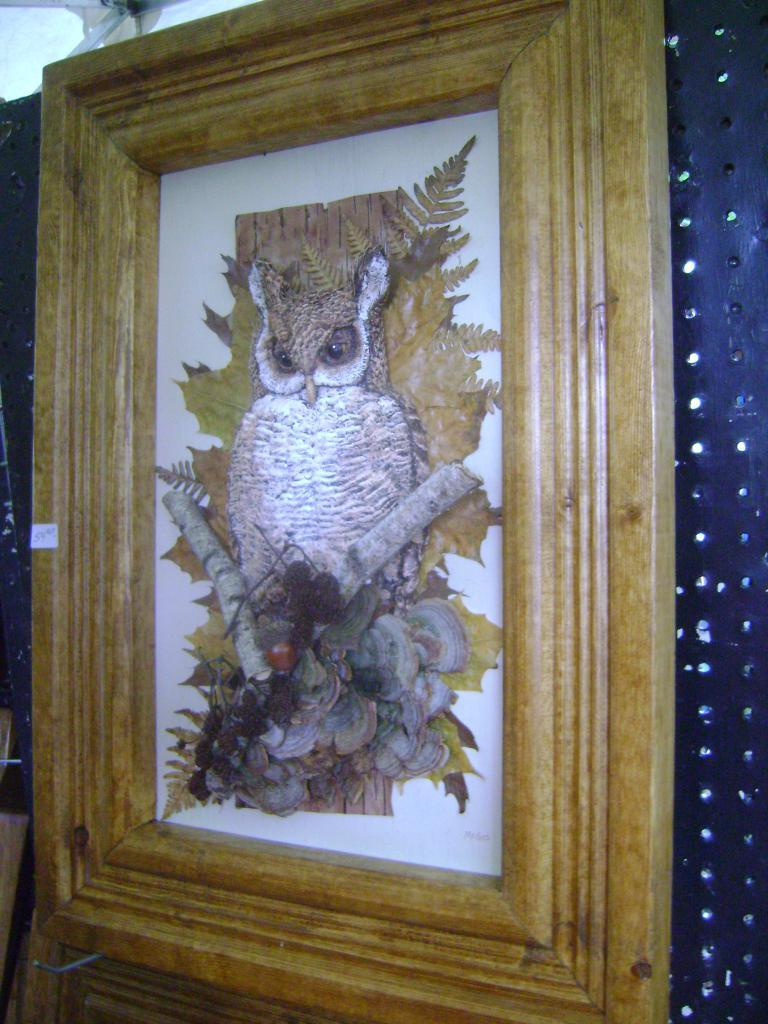What object is present in the image that typically holds a picture? There is a photo frame in the image. What type of animal can be seen in the picture inside the photo frame? There is a picture of an owl in the middle of the photo frame. What hobbies does the owl enjoy in the image? The image does not provide information about the owl's hobbies, as it is a static picture of an owl. 